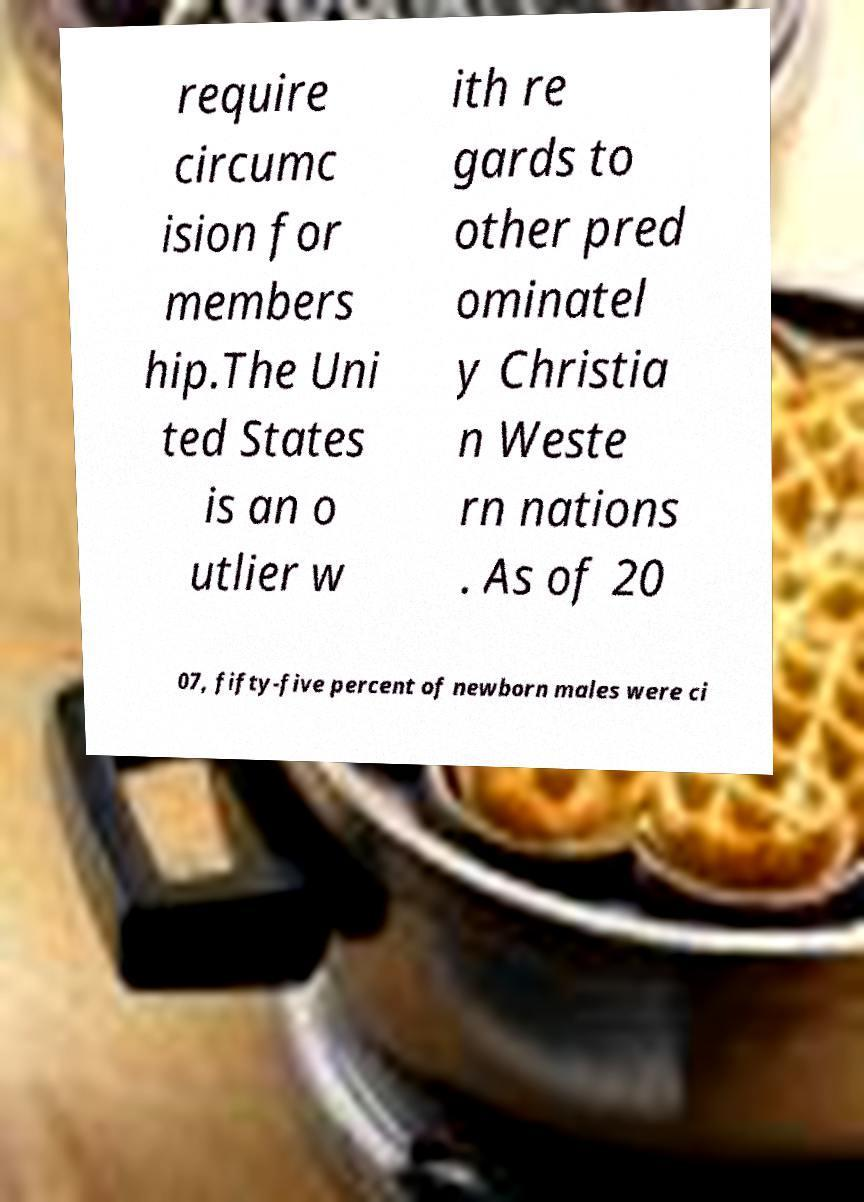What messages or text are displayed in this image? I need them in a readable, typed format. require circumc ision for members hip.The Uni ted States is an o utlier w ith re gards to other pred ominatel y Christia n Weste rn nations . As of 20 07, fifty-five percent of newborn males were ci 